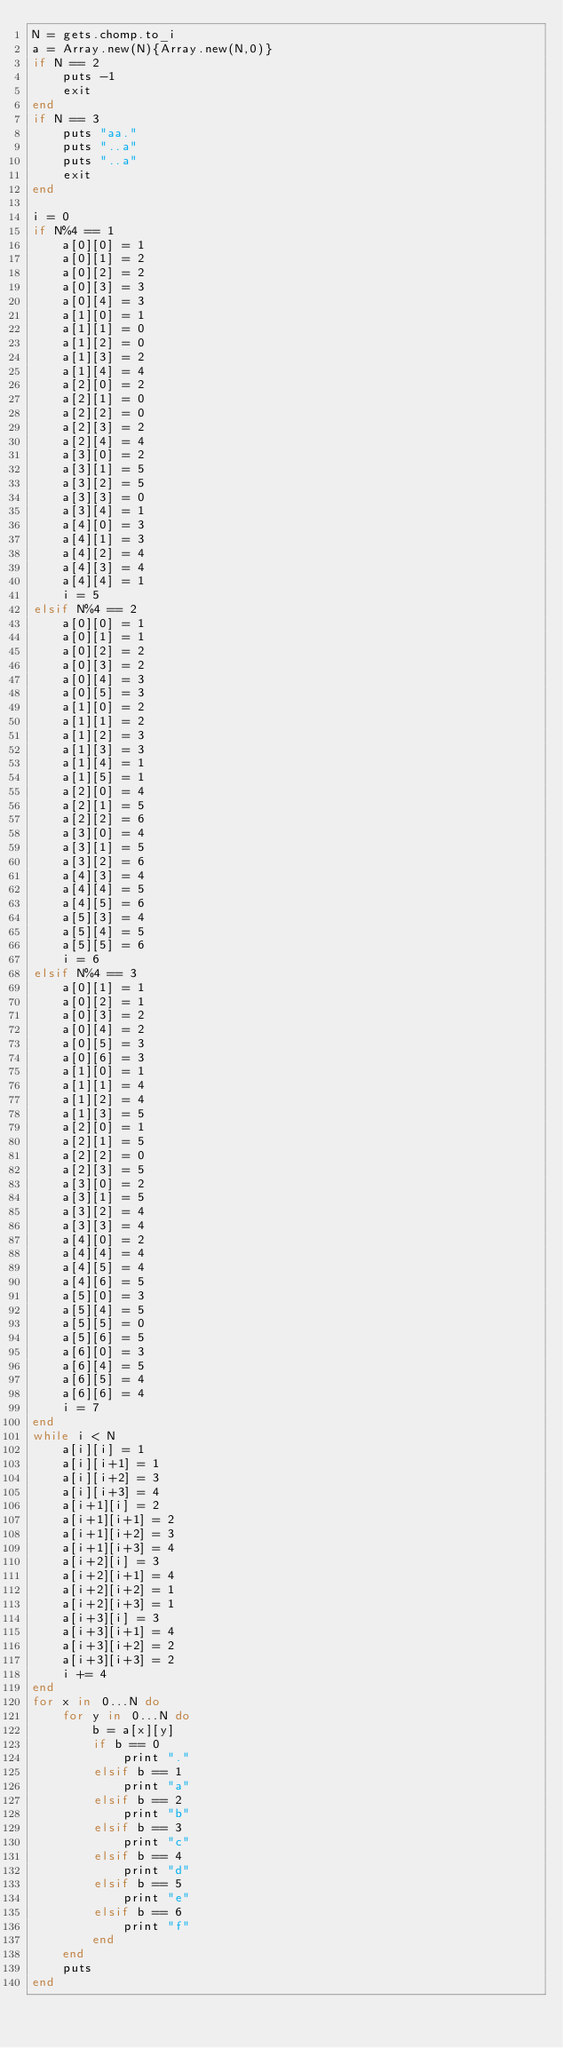Convert code to text. <code><loc_0><loc_0><loc_500><loc_500><_Ruby_>N = gets.chomp.to_i
a = Array.new(N){Array.new(N,0)}
if N == 2
    puts -1
    exit
end
if N == 3
    puts "aa."
    puts "..a"
    puts "..a"
    exit
end

i = 0
if N%4 == 1
    a[0][0] = 1
    a[0][1] = 2
    a[0][2] = 2
    a[0][3] = 3
    a[0][4] = 3
    a[1][0] = 1
    a[1][1] = 0
    a[1][2] = 0
    a[1][3] = 2
    a[1][4] = 4
    a[2][0] = 2
    a[2][1] = 0
    a[2][2] = 0
    a[2][3] = 2
    a[2][4] = 4
    a[3][0] = 2
    a[3][1] = 5
    a[3][2] = 5
    a[3][3] = 0
    a[3][4] = 1
    a[4][0] = 3
    a[4][1] = 3
    a[4][2] = 4
    a[4][3] = 4
    a[4][4] = 1
    i = 5
elsif N%4 == 2
    a[0][0] = 1
    a[0][1] = 1
    a[0][2] = 2
    a[0][3] = 2
    a[0][4] = 3
    a[0][5] = 3
    a[1][0] = 2
    a[1][1] = 2
    a[1][2] = 3
    a[1][3] = 3
    a[1][4] = 1
    a[1][5] = 1
    a[2][0] = 4
    a[2][1] = 5
    a[2][2] = 6
    a[3][0] = 4
    a[3][1] = 5
    a[3][2] = 6
    a[4][3] = 4
    a[4][4] = 5
    a[4][5] = 6
    a[5][3] = 4
    a[5][4] = 5
    a[5][5] = 6
    i = 6
elsif N%4 == 3
    a[0][1] = 1
    a[0][2] = 1
    a[0][3] = 2
    a[0][4] = 2
    a[0][5] = 3
    a[0][6] = 3
    a[1][0] = 1
    a[1][1] = 4
    a[1][2] = 4
    a[1][3] = 5
    a[2][0] = 1
    a[2][1] = 5
    a[2][2] = 0
    a[2][3] = 5
    a[3][0] = 2
    a[3][1] = 5
    a[3][2] = 4
    a[3][3] = 4
    a[4][0] = 2
    a[4][4] = 4
    a[4][5] = 4
    a[4][6] = 5
    a[5][0] = 3
    a[5][4] = 5
    a[5][5] = 0
    a[5][6] = 5
    a[6][0] = 3
    a[6][4] = 5
    a[6][5] = 4
    a[6][6] = 4
    i = 7
end
while i < N
    a[i][i] = 1
    a[i][i+1] = 1
    a[i][i+2] = 3
    a[i][i+3] = 4
    a[i+1][i] = 2
    a[i+1][i+1] = 2
    a[i+1][i+2] = 3
    a[i+1][i+3] = 4
    a[i+2][i] = 3
    a[i+2][i+1] = 4
    a[i+2][i+2] = 1
    a[i+2][i+3] = 1
    a[i+3][i] = 3
    a[i+3][i+1] = 4
    a[i+3][i+2] = 2
    a[i+3][i+3] = 2
    i += 4
end
for x in 0...N do
    for y in 0...N do
        b = a[x][y]
        if b == 0
            print "."
        elsif b == 1
            print "a"
        elsif b == 2
            print "b"
        elsif b == 3
            print "c"
        elsif b == 4
            print "d"
        elsif b == 5
            print "e"
        elsif b == 6
            print "f"
        end
    end
    puts
end</code> 